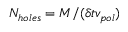Convert formula to latex. <formula><loc_0><loc_0><loc_500><loc_500>N _ { h o l e s } = M / ( \delta t v _ { p o l } )</formula> 